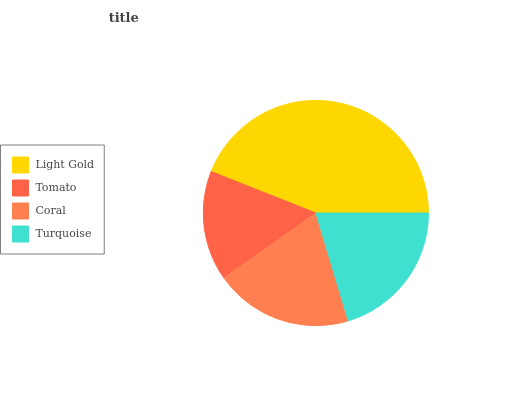Is Tomato the minimum?
Answer yes or no. Yes. Is Light Gold the maximum?
Answer yes or no. Yes. Is Coral the minimum?
Answer yes or no. No. Is Coral the maximum?
Answer yes or no. No. Is Coral greater than Tomato?
Answer yes or no. Yes. Is Tomato less than Coral?
Answer yes or no. Yes. Is Tomato greater than Coral?
Answer yes or no. No. Is Coral less than Tomato?
Answer yes or no. No. Is Turquoise the high median?
Answer yes or no. Yes. Is Coral the low median?
Answer yes or no. Yes. Is Tomato the high median?
Answer yes or no. No. Is Turquoise the low median?
Answer yes or no. No. 